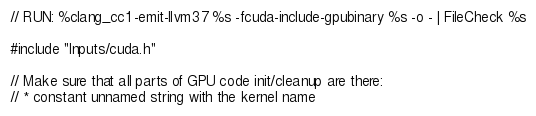<code> <loc_0><loc_0><loc_500><loc_500><_Cuda_>// RUN: %clang_cc1 -emit-llvm37 %s -fcuda-include-gpubinary %s -o - | FileCheck %s

#include "Inputs/cuda.h"

// Make sure that all parts of GPU code init/cleanup are there:
// * constant unnamed string with the kernel name</code> 